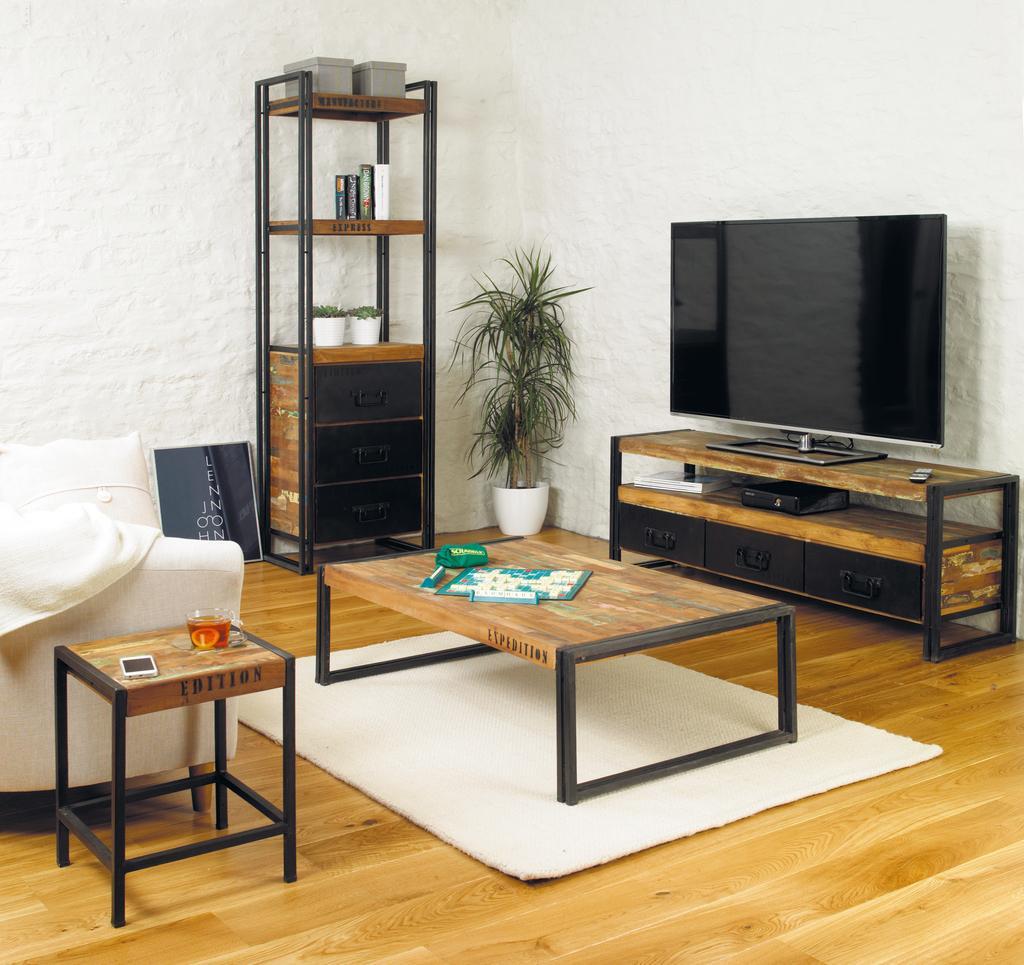Describe this image in one or two sentences. There is a table in the middle of the room. There is a book ,sketch on a table. There is a another table on the right side of the room. There is a TV,remote on a table. There is a stool on the left side of the room. There is a mobile,bowl on a stool. We can see in background sofa,wall,carpet and flower plant. 